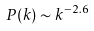<formula> <loc_0><loc_0><loc_500><loc_500>P ( k ) \sim k ^ { - 2 . 6 }</formula> 